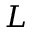Convert formula to latex. <formula><loc_0><loc_0><loc_500><loc_500>L</formula> 